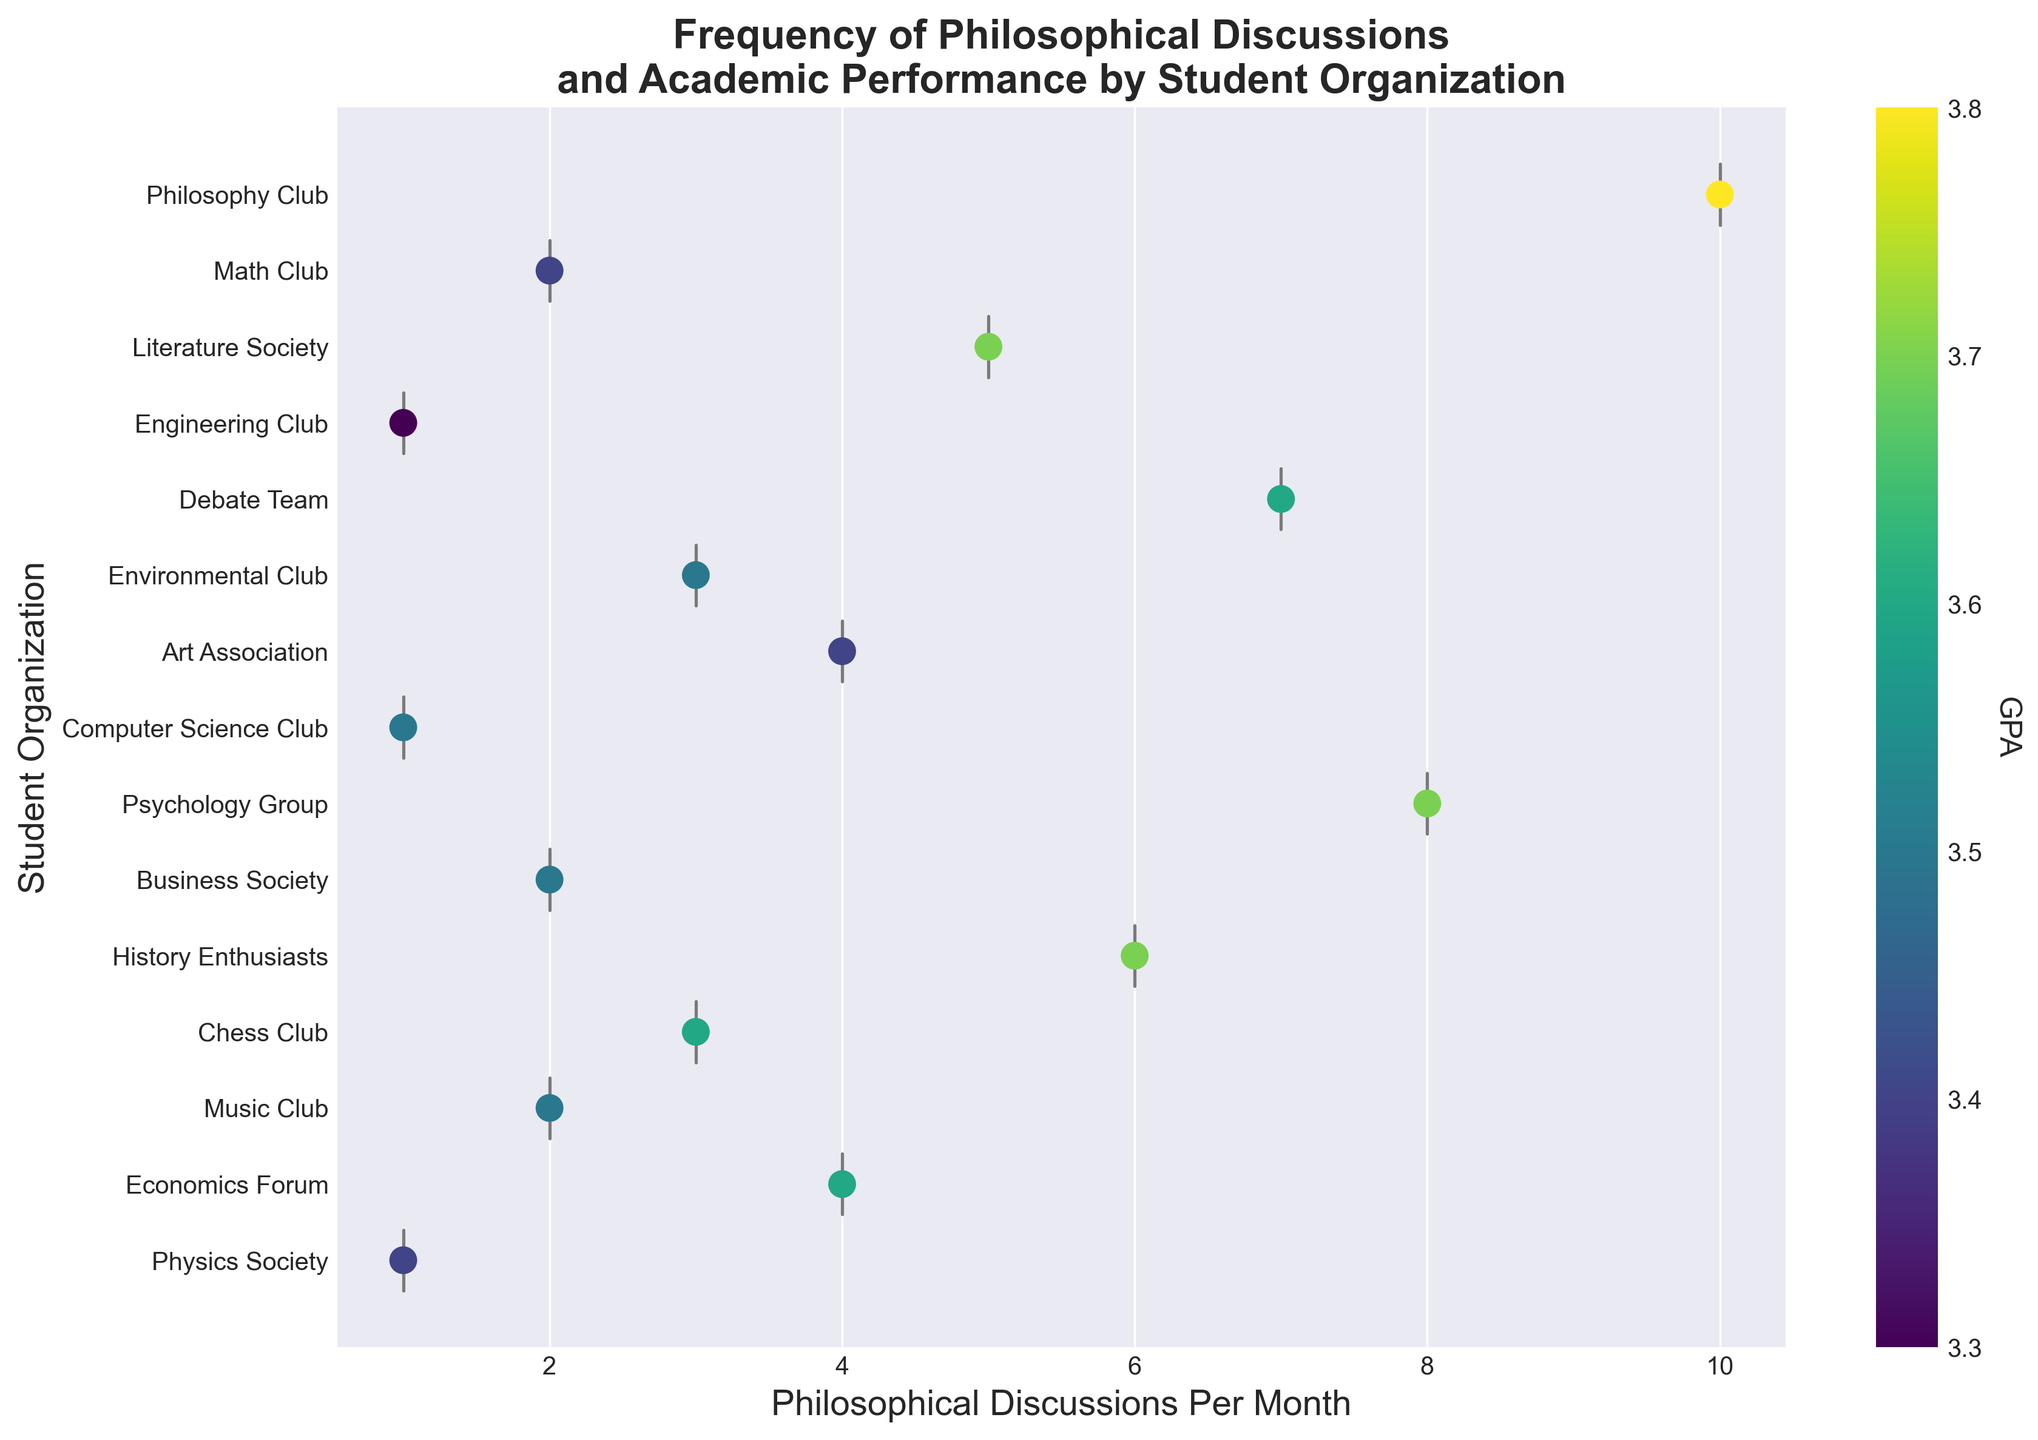What is the title of the figure? The title is located at the top of the figure and is often bolded and larger than other text in the plot, indicating what the plot is about.
Answer: Frequency of Philosophical Discussions and Academic Performance by Student Organization How many student organizations are included in this figure? Each organization is listed on the y-axis. By counting these labels, we can determine how many unique student organizations are represented.
Answer: 15 Which student organization holds the most philosophical discussions per month? By identifying the x-axis position corresponding to the maximum value for Philosophical Discussions Per Month and cross-referencing with the y-axis labels, we can determine the organization.
Answer: Philosophy Club What is the range of philosophical discussions per month for the Debate Team? The violin plot provides a graphical representation of the distribution. By observing the extent of the violin plot for the Debate Team, we can identify the range.
Answer: Approximately 5 to 8 What organization has the lowest range of philosophical discussions per month? The organization where the violin plot is the narrowest, indicating the least variation or range in discussions per month, represents this condition.
Answer: Computer Science Club and Engineering Club How does GPA vary across organizations on the violin chart? By examining the color gradient of the scatter points, where color intensity indicates GPA values, you can observe the distribution and levels of GPA across different organizations.
Answer: GPA varies from approximately 3.3 to 3.8 For the organizations with only one discussion per month, what is the range of GPAs? Identify the data points (scatter points) on the x-axis at the position corresponding to one discussion per month, then observe the range of colors (GPA) for those points.
Answer: 3.3 to 3.5 Which organizations have a meeting frequency of four discussions per month and what are their GPAs? Locate the points along the x-axis at four discussions per month and cross-reference with the y-axis to identify the organizations and their associated colors (GPA) on the scatter plot.
Answer: Art Association and Economics Forum (GPA 3.4 and 3.6) Is there a visible relationship between the frequency of philosophical discussions and GPA? By examining the overall distribution of the scatter points and their color intensities across different discussion frequencies, we can infer potential patterns or correlations.
Answer: Organizations with more discussions per month have slightly higher GPAs, but other variables may affect this relationship Which organization has a higher median number of philosophical discussions per month, Math Club or Literature Society? By observing the central box within the violin plots for both organizations, the organization with a higher median value will have the box positioned further to the right on the x-axis.
Answer: Literature Society 